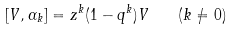<formula> <loc_0><loc_0><loc_500><loc_500>[ V , \alpha _ { k } ] = z ^ { k } ( 1 - q ^ { k } ) V \quad ( k \not = 0 )</formula> 